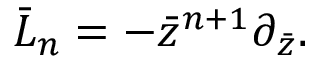<formula> <loc_0><loc_0><loc_500><loc_500>\bar { L } _ { n } = - \bar { z } ^ { n + 1 } \partial _ { \bar { z } } .</formula> 